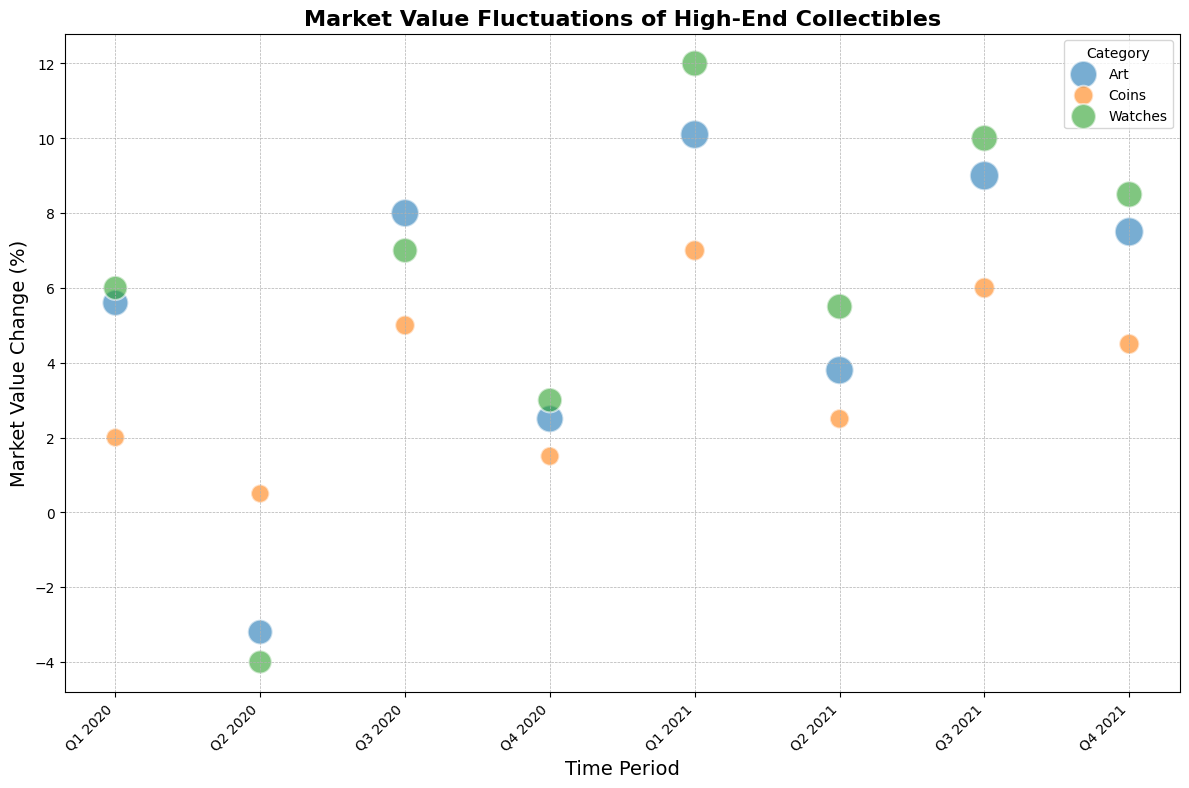What category showed the largest market value change in Q1 2021? To identify which category showed the largest market value change in Q1 2021, look for the bubbles associated with Q1 2021 and find the one with the highest value on the y-axis. The largest market value change in Q1 2021 is associated with Watches at 12.0%.
Answer: Watches Compare the market value change of Art between Q2 2020 and Q3 2021. Which one is higher? To compare the market value changes, find the bubbles for Art in Q2 2020 and Q3 2021. Q2 2020 has a value of -3.2%, whereas Q3 2021 has a value of 9.0%. Hence, Q3 2021 is higher.
Answer: Q3 2021 What is the difference in market value change between Coins and Watches in Q4 2020? Find the bubbles for Coins and Watches in Q4 2020. Coins have a value of 1.5%, and Watches have a value of 3.0%. The difference is 3.0% - 1.5% = 1.5%.
Answer: 1.5% Which time period saw a negative market value change for both Art and Watches? Look for the time period where both Art and Watches show negative values on the y-axis. Q2 2020 is this period, with Art at -3.2% and Watches at -4.0%.
Answer: Q2 2020 Among all categories, which one had the smallest bubble size in the entire data set? Identifying the smallest bubble requires checking the size attribute of the bubbles. The smallest bubble size is 175, which is associated with Coins in Q2 2020.
Answer: Coins in Q2 2020 What is the average market value change for Coins in 2021? Calculate the average by summing the market value changes for Coins in Q1 2021, Q2 2021, Q3 2021, and Q4 2021, then divide by 4. The sum is 7.0% + 2.5% + 6.0% + 4.5% = 20.0%, hence the average is 20.0% / 4 = 5.0%.
Answer: 5.0% Between Q3 2020 and Q3 2021, how did the market value change for Art compare? For a comparison, observe Art's market value change in Q3 2020 at 8.0% and in Q3 2021 at 9.0%. Thus, Art's market value change increased by 1.0%.
Answer: Increased by 1.0% Which category had the highest market value change in Q2 2021? Check the values of all categories in Q2 2021. Art is at 3.8%, Coins at 2.5%, and Watches at 5.5%. Watches had the highest market value change.
Answer: Watches 